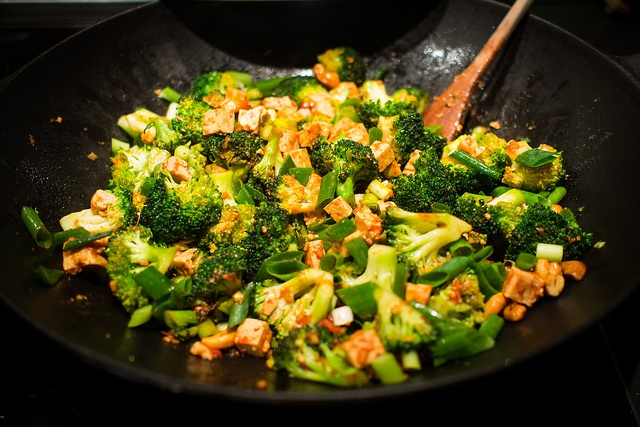Describe the objects in this image and their specific colors. I can see broccoli in black, olive, and orange tones, broccoli in black, khaki, darkgreen, and olive tones, broccoli in black, darkgreen, and olive tones, broccoli in black, darkgreen, and olive tones, and broccoli in black, darkgreen, and gold tones in this image. 